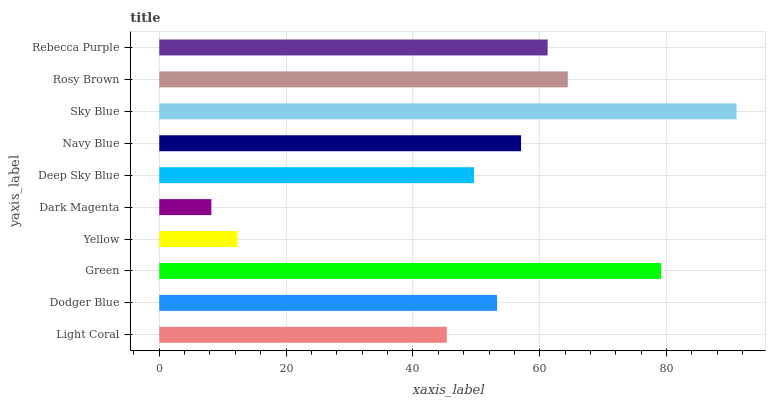Is Dark Magenta the minimum?
Answer yes or no. Yes. Is Sky Blue the maximum?
Answer yes or no. Yes. Is Dodger Blue the minimum?
Answer yes or no. No. Is Dodger Blue the maximum?
Answer yes or no. No. Is Dodger Blue greater than Light Coral?
Answer yes or no. Yes. Is Light Coral less than Dodger Blue?
Answer yes or no. Yes. Is Light Coral greater than Dodger Blue?
Answer yes or no. No. Is Dodger Blue less than Light Coral?
Answer yes or no. No. Is Navy Blue the high median?
Answer yes or no. Yes. Is Dodger Blue the low median?
Answer yes or no. Yes. Is Dodger Blue the high median?
Answer yes or no. No. Is Sky Blue the low median?
Answer yes or no. No. 